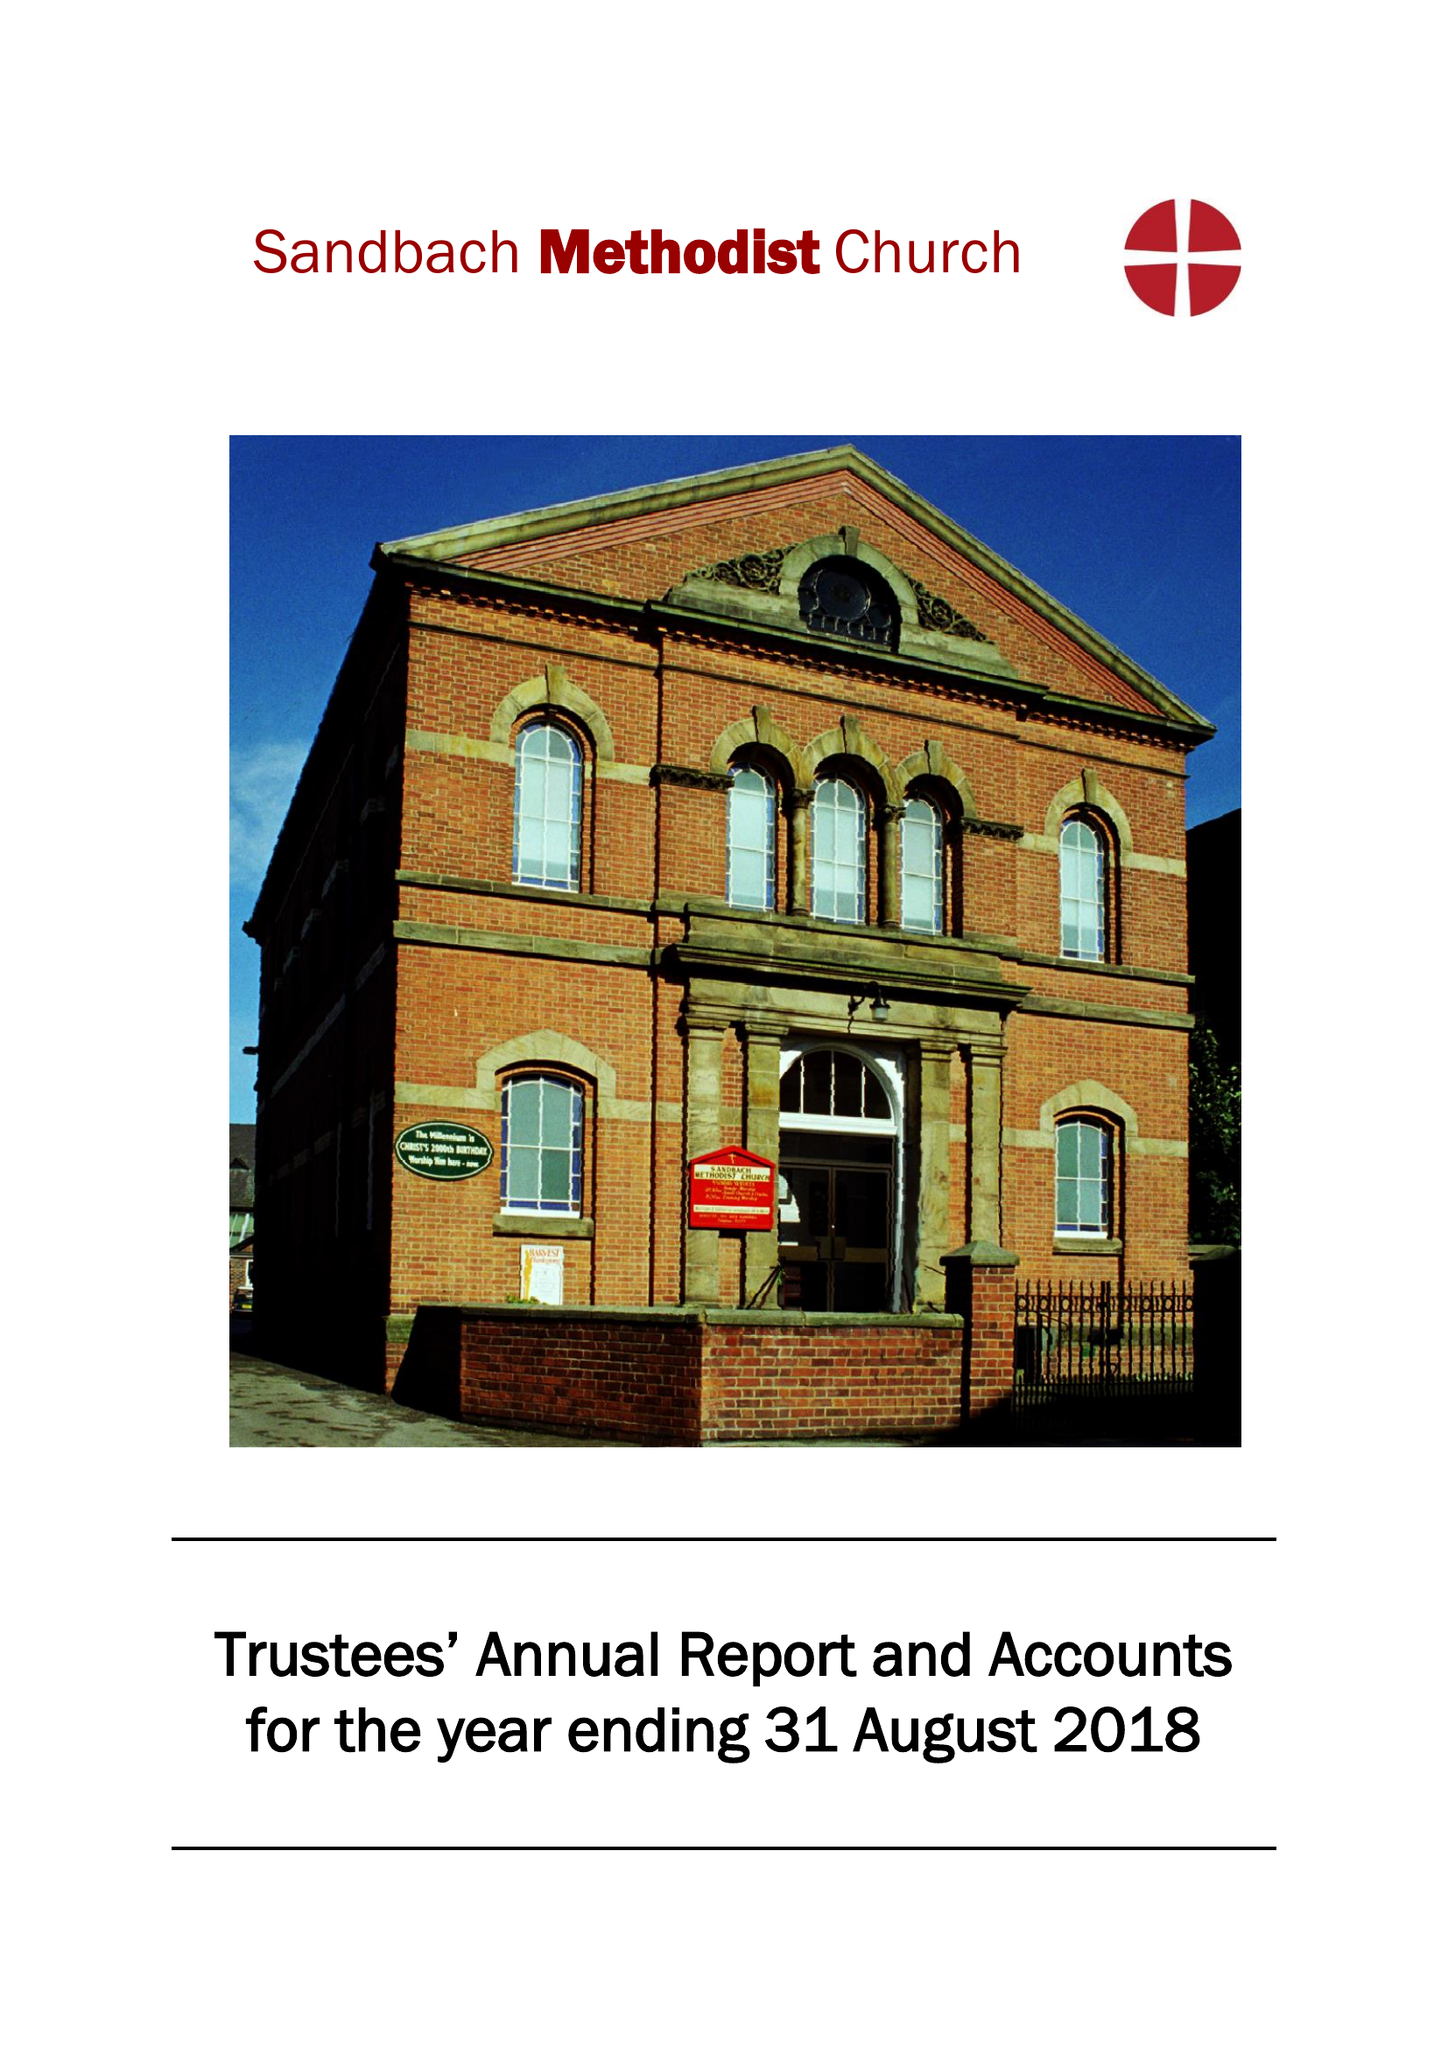What is the value for the income_annually_in_british_pounds?
Answer the question using a single word or phrase. 91030.00 